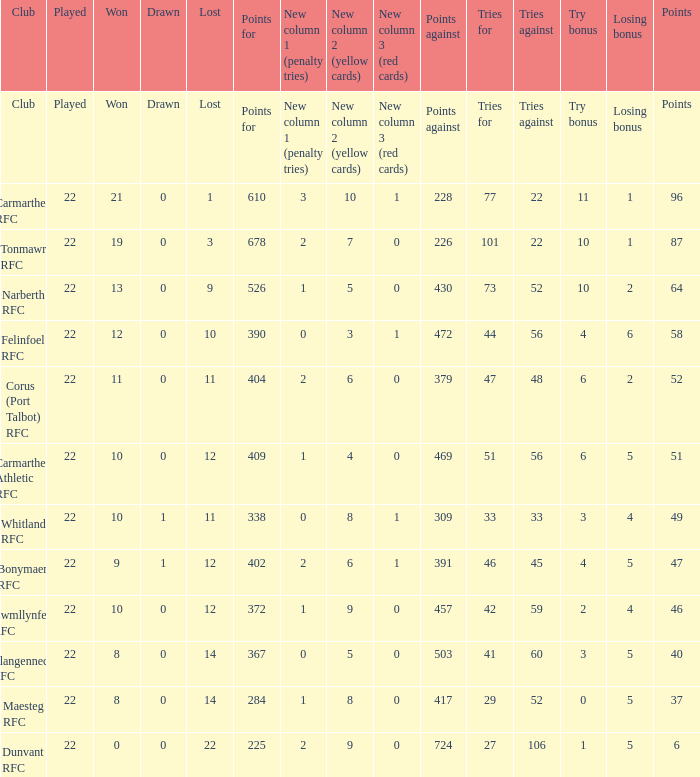Name the tries against for 87 points 22.0. 